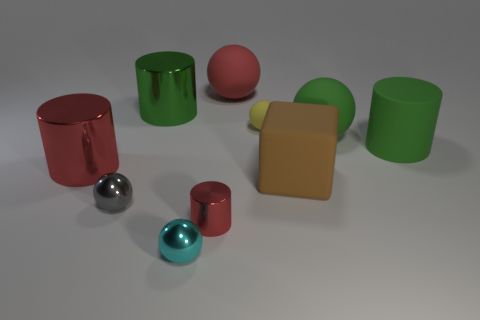Is the number of green metallic objects on the right side of the big brown cube less than the number of shiny cylinders behind the matte cylinder?
Ensure brevity in your answer.  Yes. Is the size of the green matte cylinder the same as the cylinder that is in front of the large brown rubber thing?
Keep it short and to the point. No. What is the shape of the large object that is both right of the cyan thing and to the left of the brown cube?
Provide a short and direct response. Sphere. What size is the green thing that is made of the same material as the cyan ball?
Your answer should be compact. Large. What number of big rubber spheres are left of the large brown rubber block that is behind the gray metal object?
Provide a succinct answer. 1. Are the small ball behind the brown rubber object and the big brown block made of the same material?
Make the answer very short. Yes. There is a metal object behind the large cylinder on the right side of the green rubber ball; what size is it?
Provide a succinct answer. Large. What is the size of the yellow matte sphere that is on the left side of the big rubber sphere that is in front of the big green object to the left of the green matte sphere?
Your answer should be compact. Small. Does the tiny shiny object that is right of the tiny cyan ball have the same shape as the red thing that is left of the tiny shiny cylinder?
Provide a short and direct response. Yes. What number of other objects are there of the same color as the cube?
Provide a short and direct response. 0. 